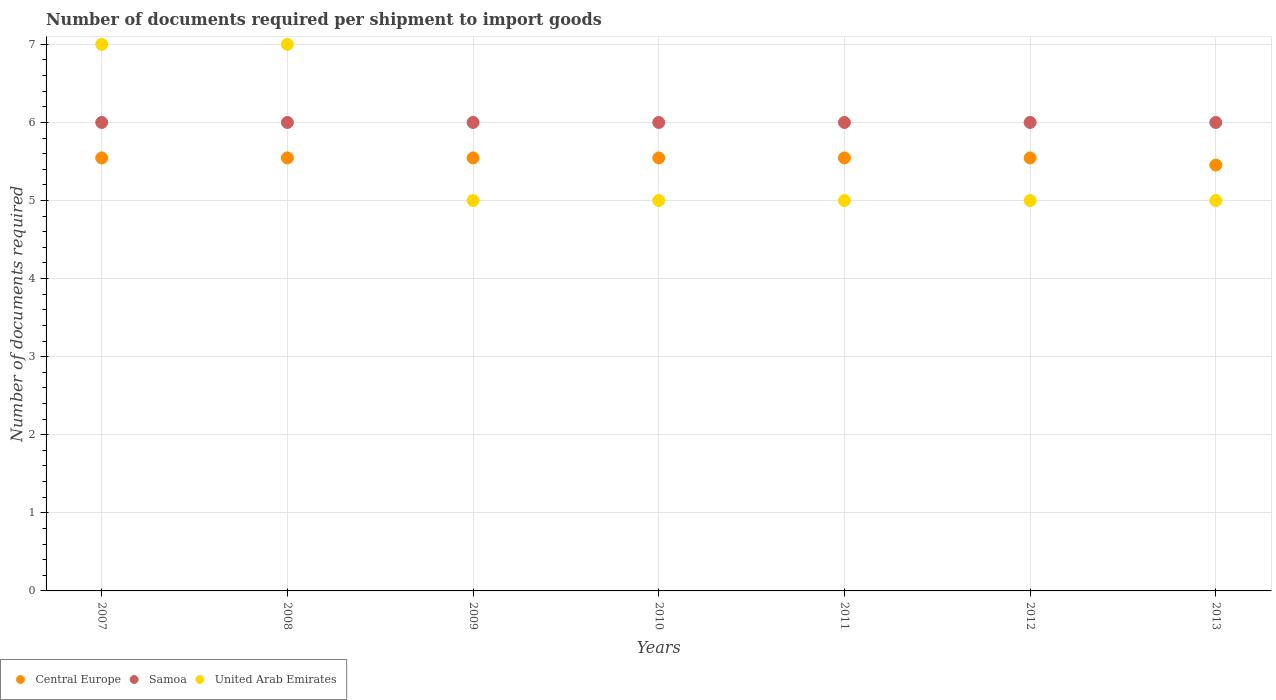Across all years, what is the maximum number of documents required per shipment to import goods in United Arab Emirates?
Ensure brevity in your answer.  7. In which year was the number of documents required per shipment to import goods in Central Europe maximum?
Ensure brevity in your answer.  2007. In which year was the number of documents required per shipment to import goods in Samoa minimum?
Your response must be concise. 2007. What is the total number of documents required per shipment to import goods in United Arab Emirates in the graph?
Your answer should be compact. 39. What is the difference between the number of documents required per shipment to import goods in Central Europe in 2009 and the number of documents required per shipment to import goods in Samoa in 2007?
Offer a very short reply. -0.45. What is the average number of documents required per shipment to import goods in United Arab Emirates per year?
Offer a very short reply. 5.57. In the year 2008, what is the difference between the number of documents required per shipment to import goods in Central Europe and number of documents required per shipment to import goods in United Arab Emirates?
Give a very brief answer. -1.45. In how many years, is the number of documents required per shipment to import goods in Central Europe greater than 3.2?
Offer a very short reply. 7. Is the number of documents required per shipment to import goods in United Arab Emirates in 2008 less than that in 2013?
Your answer should be compact. No. What is the difference between the highest and the second highest number of documents required per shipment to import goods in Samoa?
Keep it short and to the point. 0. What is the difference between the highest and the lowest number of documents required per shipment to import goods in Samoa?
Provide a short and direct response. 0. How many years are there in the graph?
Provide a succinct answer. 7. Does the graph contain any zero values?
Provide a succinct answer. No. Does the graph contain grids?
Provide a succinct answer. Yes. How are the legend labels stacked?
Provide a succinct answer. Horizontal. What is the title of the graph?
Provide a succinct answer. Number of documents required per shipment to import goods. Does "Pakistan" appear as one of the legend labels in the graph?
Give a very brief answer. No. What is the label or title of the Y-axis?
Provide a succinct answer. Number of documents required. What is the Number of documents required in Central Europe in 2007?
Keep it short and to the point. 5.55. What is the Number of documents required in Central Europe in 2008?
Your answer should be very brief. 5.55. What is the Number of documents required in United Arab Emirates in 2008?
Give a very brief answer. 7. What is the Number of documents required of Central Europe in 2009?
Give a very brief answer. 5.55. What is the Number of documents required of Samoa in 2009?
Ensure brevity in your answer.  6. What is the Number of documents required in United Arab Emirates in 2009?
Keep it short and to the point. 5. What is the Number of documents required in Central Europe in 2010?
Offer a terse response. 5.55. What is the Number of documents required of United Arab Emirates in 2010?
Make the answer very short. 5. What is the Number of documents required in Central Europe in 2011?
Offer a terse response. 5.55. What is the Number of documents required in United Arab Emirates in 2011?
Provide a succinct answer. 5. What is the Number of documents required of Central Europe in 2012?
Provide a succinct answer. 5.55. What is the Number of documents required in Samoa in 2012?
Keep it short and to the point. 6. What is the Number of documents required of Central Europe in 2013?
Keep it short and to the point. 5.45. Across all years, what is the maximum Number of documents required of Central Europe?
Provide a succinct answer. 5.55. Across all years, what is the minimum Number of documents required of Central Europe?
Offer a terse response. 5.45. What is the total Number of documents required of Central Europe in the graph?
Your response must be concise. 38.73. What is the total Number of documents required of Samoa in the graph?
Provide a short and direct response. 42. What is the difference between the Number of documents required in Central Europe in 2007 and that in 2008?
Offer a terse response. 0. What is the difference between the Number of documents required of Samoa in 2007 and that in 2008?
Ensure brevity in your answer.  0. What is the difference between the Number of documents required in Central Europe in 2007 and that in 2009?
Ensure brevity in your answer.  0. What is the difference between the Number of documents required in Samoa in 2007 and that in 2009?
Provide a short and direct response. 0. What is the difference between the Number of documents required in United Arab Emirates in 2007 and that in 2010?
Offer a very short reply. 2. What is the difference between the Number of documents required of United Arab Emirates in 2007 and that in 2012?
Keep it short and to the point. 2. What is the difference between the Number of documents required of Central Europe in 2007 and that in 2013?
Keep it short and to the point. 0.09. What is the difference between the Number of documents required of Samoa in 2007 and that in 2013?
Provide a short and direct response. 0. What is the difference between the Number of documents required of United Arab Emirates in 2007 and that in 2013?
Provide a short and direct response. 2. What is the difference between the Number of documents required in Central Europe in 2008 and that in 2009?
Offer a terse response. 0. What is the difference between the Number of documents required of United Arab Emirates in 2008 and that in 2009?
Provide a short and direct response. 2. What is the difference between the Number of documents required in United Arab Emirates in 2008 and that in 2010?
Give a very brief answer. 2. What is the difference between the Number of documents required of Central Europe in 2008 and that in 2011?
Your answer should be very brief. 0. What is the difference between the Number of documents required in United Arab Emirates in 2008 and that in 2011?
Provide a short and direct response. 2. What is the difference between the Number of documents required in Central Europe in 2008 and that in 2012?
Give a very brief answer. 0. What is the difference between the Number of documents required in Central Europe in 2008 and that in 2013?
Your response must be concise. 0.09. What is the difference between the Number of documents required in Samoa in 2008 and that in 2013?
Your answer should be compact. 0. What is the difference between the Number of documents required in Central Europe in 2009 and that in 2010?
Make the answer very short. 0. What is the difference between the Number of documents required in Samoa in 2009 and that in 2010?
Your answer should be very brief. 0. What is the difference between the Number of documents required of Samoa in 2009 and that in 2011?
Provide a short and direct response. 0. What is the difference between the Number of documents required in United Arab Emirates in 2009 and that in 2011?
Make the answer very short. 0. What is the difference between the Number of documents required in Central Europe in 2009 and that in 2012?
Make the answer very short. 0. What is the difference between the Number of documents required of Samoa in 2009 and that in 2012?
Ensure brevity in your answer.  0. What is the difference between the Number of documents required in Central Europe in 2009 and that in 2013?
Keep it short and to the point. 0.09. What is the difference between the Number of documents required of Samoa in 2009 and that in 2013?
Ensure brevity in your answer.  0. What is the difference between the Number of documents required of Samoa in 2010 and that in 2011?
Offer a very short reply. 0. What is the difference between the Number of documents required in Central Europe in 2010 and that in 2012?
Give a very brief answer. 0. What is the difference between the Number of documents required in Samoa in 2010 and that in 2012?
Give a very brief answer. 0. What is the difference between the Number of documents required of Central Europe in 2010 and that in 2013?
Keep it short and to the point. 0.09. What is the difference between the Number of documents required in United Arab Emirates in 2010 and that in 2013?
Provide a succinct answer. 0. What is the difference between the Number of documents required of Central Europe in 2011 and that in 2012?
Provide a succinct answer. 0. What is the difference between the Number of documents required of Samoa in 2011 and that in 2012?
Ensure brevity in your answer.  0. What is the difference between the Number of documents required in United Arab Emirates in 2011 and that in 2012?
Keep it short and to the point. 0. What is the difference between the Number of documents required of Central Europe in 2011 and that in 2013?
Your response must be concise. 0.09. What is the difference between the Number of documents required of Samoa in 2011 and that in 2013?
Your answer should be very brief. 0. What is the difference between the Number of documents required in United Arab Emirates in 2011 and that in 2013?
Ensure brevity in your answer.  0. What is the difference between the Number of documents required in Central Europe in 2012 and that in 2013?
Give a very brief answer. 0.09. What is the difference between the Number of documents required of Central Europe in 2007 and the Number of documents required of Samoa in 2008?
Make the answer very short. -0.45. What is the difference between the Number of documents required in Central Europe in 2007 and the Number of documents required in United Arab Emirates in 2008?
Provide a short and direct response. -1.45. What is the difference between the Number of documents required of Central Europe in 2007 and the Number of documents required of Samoa in 2009?
Make the answer very short. -0.45. What is the difference between the Number of documents required of Central Europe in 2007 and the Number of documents required of United Arab Emirates in 2009?
Your answer should be compact. 0.55. What is the difference between the Number of documents required in Samoa in 2007 and the Number of documents required in United Arab Emirates in 2009?
Provide a short and direct response. 1. What is the difference between the Number of documents required in Central Europe in 2007 and the Number of documents required in Samoa in 2010?
Offer a terse response. -0.45. What is the difference between the Number of documents required of Central Europe in 2007 and the Number of documents required of United Arab Emirates in 2010?
Make the answer very short. 0.55. What is the difference between the Number of documents required of Central Europe in 2007 and the Number of documents required of Samoa in 2011?
Give a very brief answer. -0.45. What is the difference between the Number of documents required in Central Europe in 2007 and the Number of documents required in United Arab Emirates in 2011?
Ensure brevity in your answer.  0.55. What is the difference between the Number of documents required in Samoa in 2007 and the Number of documents required in United Arab Emirates in 2011?
Make the answer very short. 1. What is the difference between the Number of documents required in Central Europe in 2007 and the Number of documents required in Samoa in 2012?
Your response must be concise. -0.45. What is the difference between the Number of documents required in Central Europe in 2007 and the Number of documents required in United Arab Emirates in 2012?
Make the answer very short. 0.55. What is the difference between the Number of documents required in Samoa in 2007 and the Number of documents required in United Arab Emirates in 2012?
Your response must be concise. 1. What is the difference between the Number of documents required of Central Europe in 2007 and the Number of documents required of Samoa in 2013?
Your answer should be very brief. -0.45. What is the difference between the Number of documents required in Central Europe in 2007 and the Number of documents required in United Arab Emirates in 2013?
Keep it short and to the point. 0.55. What is the difference between the Number of documents required in Samoa in 2007 and the Number of documents required in United Arab Emirates in 2013?
Your response must be concise. 1. What is the difference between the Number of documents required of Central Europe in 2008 and the Number of documents required of Samoa in 2009?
Offer a very short reply. -0.45. What is the difference between the Number of documents required in Central Europe in 2008 and the Number of documents required in United Arab Emirates in 2009?
Offer a very short reply. 0.55. What is the difference between the Number of documents required of Central Europe in 2008 and the Number of documents required of Samoa in 2010?
Provide a short and direct response. -0.45. What is the difference between the Number of documents required in Central Europe in 2008 and the Number of documents required in United Arab Emirates in 2010?
Provide a succinct answer. 0.55. What is the difference between the Number of documents required in Samoa in 2008 and the Number of documents required in United Arab Emirates in 2010?
Keep it short and to the point. 1. What is the difference between the Number of documents required in Central Europe in 2008 and the Number of documents required in Samoa in 2011?
Ensure brevity in your answer.  -0.45. What is the difference between the Number of documents required in Central Europe in 2008 and the Number of documents required in United Arab Emirates in 2011?
Your answer should be very brief. 0.55. What is the difference between the Number of documents required in Central Europe in 2008 and the Number of documents required in Samoa in 2012?
Make the answer very short. -0.45. What is the difference between the Number of documents required of Central Europe in 2008 and the Number of documents required of United Arab Emirates in 2012?
Ensure brevity in your answer.  0.55. What is the difference between the Number of documents required of Samoa in 2008 and the Number of documents required of United Arab Emirates in 2012?
Ensure brevity in your answer.  1. What is the difference between the Number of documents required of Central Europe in 2008 and the Number of documents required of Samoa in 2013?
Ensure brevity in your answer.  -0.45. What is the difference between the Number of documents required of Central Europe in 2008 and the Number of documents required of United Arab Emirates in 2013?
Make the answer very short. 0.55. What is the difference between the Number of documents required in Samoa in 2008 and the Number of documents required in United Arab Emirates in 2013?
Provide a succinct answer. 1. What is the difference between the Number of documents required in Central Europe in 2009 and the Number of documents required in Samoa in 2010?
Your response must be concise. -0.45. What is the difference between the Number of documents required in Central Europe in 2009 and the Number of documents required in United Arab Emirates in 2010?
Give a very brief answer. 0.55. What is the difference between the Number of documents required of Samoa in 2009 and the Number of documents required of United Arab Emirates in 2010?
Your answer should be very brief. 1. What is the difference between the Number of documents required in Central Europe in 2009 and the Number of documents required in Samoa in 2011?
Offer a very short reply. -0.45. What is the difference between the Number of documents required in Central Europe in 2009 and the Number of documents required in United Arab Emirates in 2011?
Give a very brief answer. 0.55. What is the difference between the Number of documents required in Samoa in 2009 and the Number of documents required in United Arab Emirates in 2011?
Keep it short and to the point. 1. What is the difference between the Number of documents required of Central Europe in 2009 and the Number of documents required of Samoa in 2012?
Your response must be concise. -0.45. What is the difference between the Number of documents required in Central Europe in 2009 and the Number of documents required in United Arab Emirates in 2012?
Provide a short and direct response. 0.55. What is the difference between the Number of documents required in Central Europe in 2009 and the Number of documents required in Samoa in 2013?
Provide a succinct answer. -0.45. What is the difference between the Number of documents required of Central Europe in 2009 and the Number of documents required of United Arab Emirates in 2013?
Give a very brief answer. 0.55. What is the difference between the Number of documents required of Central Europe in 2010 and the Number of documents required of Samoa in 2011?
Provide a short and direct response. -0.45. What is the difference between the Number of documents required of Central Europe in 2010 and the Number of documents required of United Arab Emirates in 2011?
Provide a short and direct response. 0.55. What is the difference between the Number of documents required of Samoa in 2010 and the Number of documents required of United Arab Emirates in 2011?
Give a very brief answer. 1. What is the difference between the Number of documents required of Central Europe in 2010 and the Number of documents required of Samoa in 2012?
Offer a very short reply. -0.45. What is the difference between the Number of documents required of Central Europe in 2010 and the Number of documents required of United Arab Emirates in 2012?
Your response must be concise. 0.55. What is the difference between the Number of documents required in Central Europe in 2010 and the Number of documents required in Samoa in 2013?
Ensure brevity in your answer.  -0.45. What is the difference between the Number of documents required of Central Europe in 2010 and the Number of documents required of United Arab Emirates in 2013?
Your answer should be compact. 0.55. What is the difference between the Number of documents required in Samoa in 2010 and the Number of documents required in United Arab Emirates in 2013?
Make the answer very short. 1. What is the difference between the Number of documents required in Central Europe in 2011 and the Number of documents required in Samoa in 2012?
Offer a terse response. -0.45. What is the difference between the Number of documents required of Central Europe in 2011 and the Number of documents required of United Arab Emirates in 2012?
Make the answer very short. 0.55. What is the difference between the Number of documents required in Samoa in 2011 and the Number of documents required in United Arab Emirates in 2012?
Provide a succinct answer. 1. What is the difference between the Number of documents required in Central Europe in 2011 and the Number of documents required in Samoa in 2013?
Make the answer very short. -0.45. What is the difference between the Number of documents required in Central Europe in 2011 and the Number of documents required in United Arab Emirates in 2013?
Offer a terse response. 0.55. What is the difference between the Number of documents required in Samoa in 2011 and the Number of documents required in United Arab Emirates in 2013?
Provide a succinct answer. 1. What is the difference between the Number of documents required in Central Europe in 2012 and the Number of documents required in Samoa in 2013?
Offer a very short reply. -0.45. What is the difference between the Number of documents required of Central Europe in 2012 and the Number of documents required of United Arab Emirates in 2013?
Your answer should be very brief. 0.55. What is the average Number of documents required of Central Europe per year?
Your answer should be very brief. 5.53. What is the average Number of documents required in United Arab Emirates per year?
Ensure brevity in your answer.  5.57. In the year 2007, what is the difference between the Number of documents required in Central Europe and Number of documents required in Samoa?
Provide a short and direct response. -0.45. In the year 2007, what is the difference between the Number of documents required in Central Europe and Number of documents required in United Arab Emirates?
Your response must be concise. -1.45. In the year 2007, what is the difference between the Number of documents required in Samoa and Number of documents required in United Arab Emirates?
Provide a short and direct response. -1. In the year 2008, what is the difference between the Number of documents required of Central Europe and Number of documents required of Samoa?
Ensure brevity in your answer.  -0.45. In the year 2008, what is the difference between the Number of documents required in Central Europe and Number of documents required in United Arab Emirates?
Offer a terse response. -1.45. In the year 2009, what is the difference between the Number of documents required in Central Europe and Number of documents required in Samoa?
Your answer should be compact. -0.45. In the year 2009, what is the difference between the Number of documents required in Central Europe and Number of documents required in United Arab Emirates?
Ensure brevity in your answer.  0.55. In the year 2010, what is the difference between the Number of documents required of Central Europe and Number of documents required of Samoa?
Your answer should be compact. -0.45. In the year 2010, what is the difference between the Number of documents required in Central Europe and Number of documents required in United Arab Emirates?
Provide a succinct answer. 0.55. In the year 2011, what is the difference between the Number of documents required in Central Europe and Number of documents required in Samoa?
Ensure brevity in your answer.  -0.45. In the year 2011, what is the difference between the Number of documents required of Central Europe and Number of documents required of United Arab Emirates?
Your response must be concise. 0.55. In the year 2011, what is the difference between the Number of documents required of Samoa and Number of documents required of United Arab Emirates?
Keep it short and to the point. 1. In the year 2012, what is the difference between the Number of documents required in Central Europe and Number of documents required in Samoa?
Ensure brevity in your answer.  -0.45. In the year 2012, what is the difference between the Number of documents required of Central Europe and Number of documents required of United Arab Emirates?
Provide a short and direct response. 0.55. In the year 2012, what is the difference between the Number of documents required in Samoa and Number of documents required in United Arab Emirates?
Provide a short and direct response. 1. In the year 2013, what is the difference between the Number of documents required of Central Europe and Number of documents required of Samoa?
Ensure brevity in your answer.  -0.55. In the year 2013, what is the difference between the Number of documents required of Central Europe and Number of documents required of United Arab Emirates?
Make the answer very short. 0.45. What is the ratio of the Number of documents required of Samoa in 2007 to that in 2008?
Offer a terse response. 1. What is the ratio of the Number of documents required in Central Europe in 2007 to that in 2009?
Provide a succinct answer. 1. What is the ratio of the Number of documents required in United Arab Emirates in 2007 to that in 2009?
Offer a very short reply. 1.4. What is the ratio of the Number of documents required in Samoa in 2007 to that in 2010?
Your answer should be compact. 1. What is the ratio of the Number of documents required of United Arab Emirates in 2007 to that in 2010?
Your response must be concise. 1.4. What is the ratio of the Number of documents required of Samoa in 2007 to that in 2011?
Provide a succinct answer. 1. What is the ratio of the Number of documents required of Central Europe in 2007 to that in 2012?
Offer a very short reply. 1. What is the ratio of the Number of documents required in United Arab Emirates in 2007 to that in 2012?
Provide a succinct answer. 1.4. What is the ratio of the Number of documents required of Central Europe in 2007 to that in 2013?
Offer a terse response. 1.02. What is the ratio of the Number of documents required of Samoa in 2007 to that in 2013?
Your answer should be compact. 1. What is the ratio of the Number of documents required in Samoa in 2008 to that in 2009?
Your answer should be very brief. 1. What is the ratio of the Number of documents required in United Arab Emirates in 2008 to that in 2012?
Keep it short and to the point. 1.4. What is the ratio of the Number of documents required in Central Europe in 2008 to that in 2013?
Offer a very short reply. 1.02. What is the ratio of the Number of documents required in Samoa in 2008 to that in 2013?
Provide a succinct answer. 1. What is the ratio of the Number of documents required of Central Europe in 2009 to that in 2010?
Give a very brief answer. 1. What is the ratio of the Number of documents required in Samoa in 2009 to that in 2010?
Provide a succinct answer. 1. What is the ratio of the Number of documents required of Samoa in 2009 to that in 2011?
Provide a short and direct response. 1. What is the ratio of the Number of documents required of Central Europe in 2009 to that in 2012?
Make the answer very short. 1. What is the ratio of the Number of documents required in United Arab Emirates in 2009 to that in 2012?
Your answer should be very brief. 1. What is the ratio of the Number of documents required of Central Europe in 2009 to that in 2013?
Provide a succinct answer. 1.02. What is the ratio of the Number of documents required in Central Europe in 2010 to that in 2011?
Keep it short and to the point. 1. What is the ratio of the Number of documents required of Samoa in 2010 to that in 2012?
Make the answer very short. 1. What is the ratio of the Number of documents required of United Arab Emirates in 2010 to that in 2012?
Keep it short and to the point. 1. What is the ratio of the Number of documents required of Central Europe in 2010 to that in 2013?
Give a very brief answer. 1.02. What is the ratio of the Number of documents required in United Arab Emirates in 2010 to that in 2013?
Offer a terse response. 1. What is the ratio of the Number of documents required in Samoa in 2011 to that in 2012?
Provide a short and direct response. 1. What is the ratio of the Number of documents required of United Arab Emirates in 2011 to that in 2012?
Offer a very short reply. 1. What is the ratio of the Number of documents required in Central Europe in 2011 to that in 2013?
Offer a terse response. 1.02. What is the ratio of the Number of documents required of Central Europe in 2012 to that in 2013?
Your response must be concise. 1.02. What is the difference between the highest and the second highest Number of documents required in Central Europe?
Your response must be concise. 0. What is the difference between the highest and the second highest Number of documents required of Samoa?
Keep it short and to the point. 0. What is the difference between the highest and the second highest Number of documents required of United Arab Emirates?
Provide a short and direct response. 0. What is the difference between the highest and the lowest Number of documents required of Central Europe?
Your answer should be very brief. 0.09. 